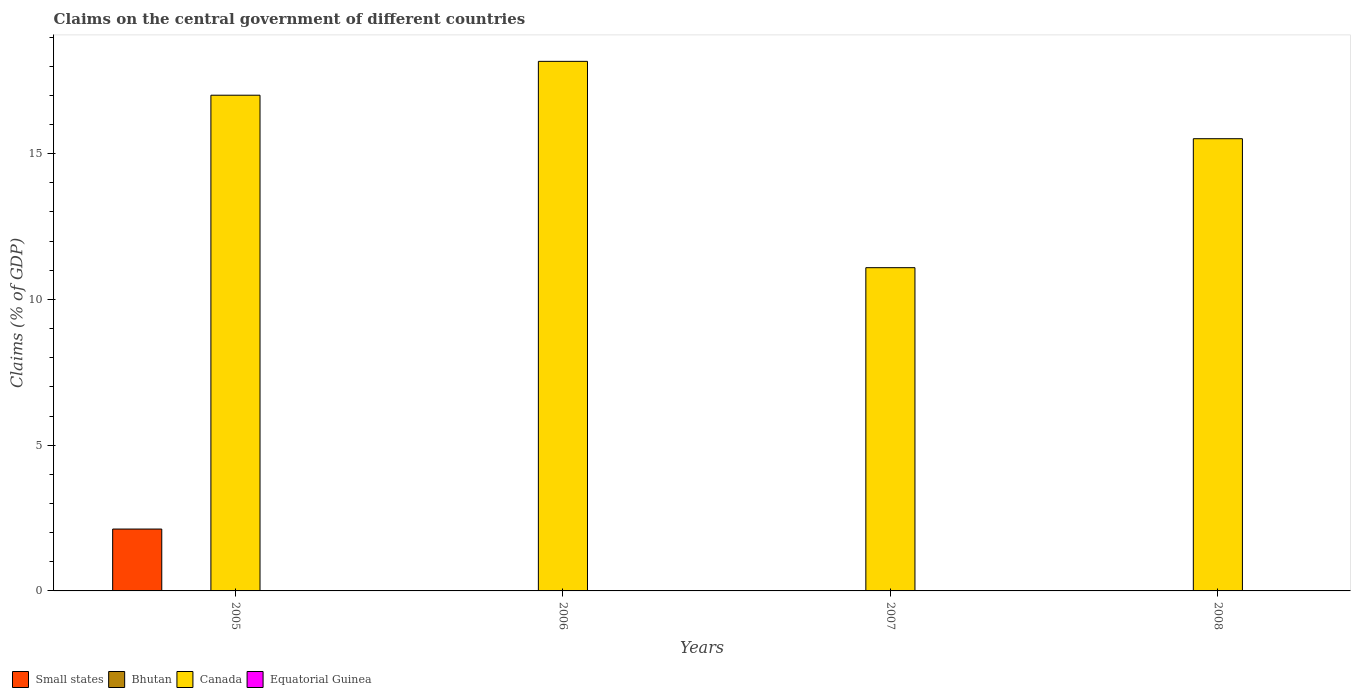How many different coloured bars are there?
Keep it short and to the point. 2. Are the number of bars per tick equal to the number of legend labels?
Ensure brevity in your answer.  No. Are the number of bars on each tick of the X-axis equal?
Make the answer very short. No. How many bars are there on the 2nd tick from the left?
Give a very brief answer. 1. What is the label of the 2nd group of bars from the left?
Make the answer very short. 2006. In how many cases, is the number of bars for a given year not equal to the number of legend labels?
Your answer should be very brief. 4. Across all years, what is the maximum percentage of GDP claimed on the central government in Small states?
Offer a terse response. 2.12. Across all years, what is the minimum percentage of GDP claimed on the central government in Canada?
Provide a succinct answer. 11.09. What is the total percentage of GDP claimed on the central government in Small states in the graph?
Provide a succinct answer. 2.12. What is the difference between the percentage of GDP claimed on the central government in Canada in 2005 and that in 2007?
Provide a short and direct response. 5.92. What is the difference between the percentage of GDP claimed on the central government in Canada in 2007 and the percentage of GDP claimed on the central government in Bhutan in 2008?
Keep it short and to the point. 11.09. What is the average percentage of GDP claimed on the central government in Small states per year?
Your answer should be very brief. 0.53. What is the ratio of the percentage of GDP claimed on the central government in Canada in 2005 to that in 2006?
Your response must be concise. 0.94. What is the difference between the highest and the second highest percentage of GDP claimed on the central government in Canada?
Your answer should be compact. 1.16. What is the difference between the highest and the lowest percentage of GDP claimed on the central government in Small states?
Your response must be concise. 2.12. Is it the case that in every year, the sum of the percentage of GDP claimed on the central government in Small states and percentage of GDP claimed on the central government in Bhutan is greater than the sum of percentage of GDP claimed on the central government in Equatorial Guinea and percentage of GDP claimed on the central government in Canada?
Offer a terse response. No. Are all the bars in the graph horizontal?
Provide a short and direct response. No. What is the difference between two consecutive major ticks on the Y-axis?
Ensure brevity in your answer.  5. Are the values on the major ticks of Y-axis written in scientific E-notation?
Make the answer very short. No. Does the graph contain grids?
Provide a short and direct response. No. What is the title of the graph?
Your answer should be very brief. Claims on the central government of different countries. Does "Middle East & North Africa (developing only)" appear as one of the legend labels in the graph?
Offer a terse response. No. What is the label or title of the Y-axis?
Your answer should be very brief. Claims (% of GDP). What is the Claims (% of GDP) of Small states in 2005?
Offer a terse response. 2.12. What is the Claims (% of GDP) in Bhutan in 2005?
Keep it short and to the point. 0. What is the Claims (% of GDP) in Canada in 2005?
Ensure brevity in your answer.  17. What is the Claims (% of GDP) of Equatorial Guinea in 2005?
Your response must be concise. 0. What is the Claims (% of GDP) in Small states in 2006?
Provide a succinct answer. 0. What is the Claims (% of GDP) of Bhutan in 2006?
Your response must be concise. 0. What is the Claims (% of GDP) in Canada in 2006?
Make the answer very short. 18.17. What is the Claims (% of GDP) of Small states in 2007?
Offer a terse response. 0. What is the Claims (% of GDP) in Canada in 2007?
Your answer should be compact. 11.09. What is the Claims (% of GDP) in Equatorial Guinea in 2007?
Your response must be concise. 0. What is the Claims (% of GDP) of Small states in 2008?
Keep it short and to the point. 0. What is the Claims (% of GDP) in Canada in 2008?
Provide a short and direct response. 15.51. What is the Claims (% of GDP) in Equatorial Guinea in 2008?
Offer a very short reply. 0. Across all years, what is the maximum Claims (% of GDP) of Small states?
Ensure brevity in your answer.  2.12. Across all years, what is the maximum Claims (% of GDP) of Canada?
Offer a very short reply. 18.17. Across all years, what is the minimum Claims (% of GDP) of Canada?
Provide a short and direct response. 11.09. What is the total Claims (% of GDP) of Small states in the graph?
Offer a very short reply. 2.12. What is the total Claims (% of GDP) of Bhutan in the graph?
Offer a very short reply. 0. What is the total Claims (% of GDP) in Canada in the graph?
Your response must be concise. 61.77. What is the difference between the Claims (% of GDP) in Canada in 2005 and that in 2006?
Offer a terse response. -1.16. What is the difference between the Claims (% of GDP) in Canada in 2005 and that in 2007?
Offer a terse response. 5.92. What is the difference between the Claims (% of GDP) of Canada in 2005 and that in 2008?
Offer a terse response. 1.49. What is the difference between the Claims (% of GDP) of Canada in 2006 and that in 2007?
Your answer should be very brief. 7.08. What is the difference between the Claims (% of GDP) in Canada in 2006 and that in 2008?
Your answer should be compact. 2.65. What is the difference between the Claims (% of GDP) of Canada in 2007 and that in 2008?
Offer a very short reply. -4.42. What is the difference between the Claims (% of GDP) of Small states in 2005 and the Claims (% of GDP) of Canada in 2006?
Ensure brevity in your answer.  -16.04. What is the difference between the Claims (% of GDP) of Small states in 2005 and the Claims (% of GDP) of Canada in 2007?
Your response must be concise. -8.97. What is the difference between the Claims (% of GDP) of Small states in 2005 and the Claims (% of GDP) of Canada in 2008?
Give a very brief answer. -13.39. What is the average Claims (% of GDP) in Small states per year?
Make the answer very short. 0.53. What is the average Claims (% of GDP) of Canada per year?
Your answer should be very brief. 15.44. In the year 2005, what is the difference between the Claims (% of GDP) of Small states and Claims (% of GDP) of Canada?
Your answer should be compact. -14.88. What is the ratio of the Claims (% of GDP) of Canada in 2005 to that in 2006?
Ensure brevity in your answer.  0.94. What is the ratio of the Claims (% of GDP) of Canada in 2005 to that in 2007?
Ensure brevity in your answer.  1.53. What is the ratio of the Claims (% of GDP) of Canada in 2005 to that in 2008?
Keep it short and to the point. 1.1. What is the ratio of the Claims (% of GDP) of Canada in 2006 to that in 2007?
Offer a terse response. 1.64. What is the ratio of the Claims (% of GDP) in Canada in 2006 to that in 2008?
Your answer should be very brief. 1.17. What is the ratio of the Claims (% of GDP) in Canada in 2007 to that in 2008?
Ensure brevity in your answer.  0.71. What is the difference between the highest and the second highest Claims (% of GDP) of Canada?
Keep it short and to the point. 1.16. What is the difference between the highest and the lowest Claims (% of GDP) in Small states?
Your response must be concise. 2.12. What is the difference between the highest and the lowest Claims (% of GDP) of Canada?
Provide a short and direct response. 7.08. 